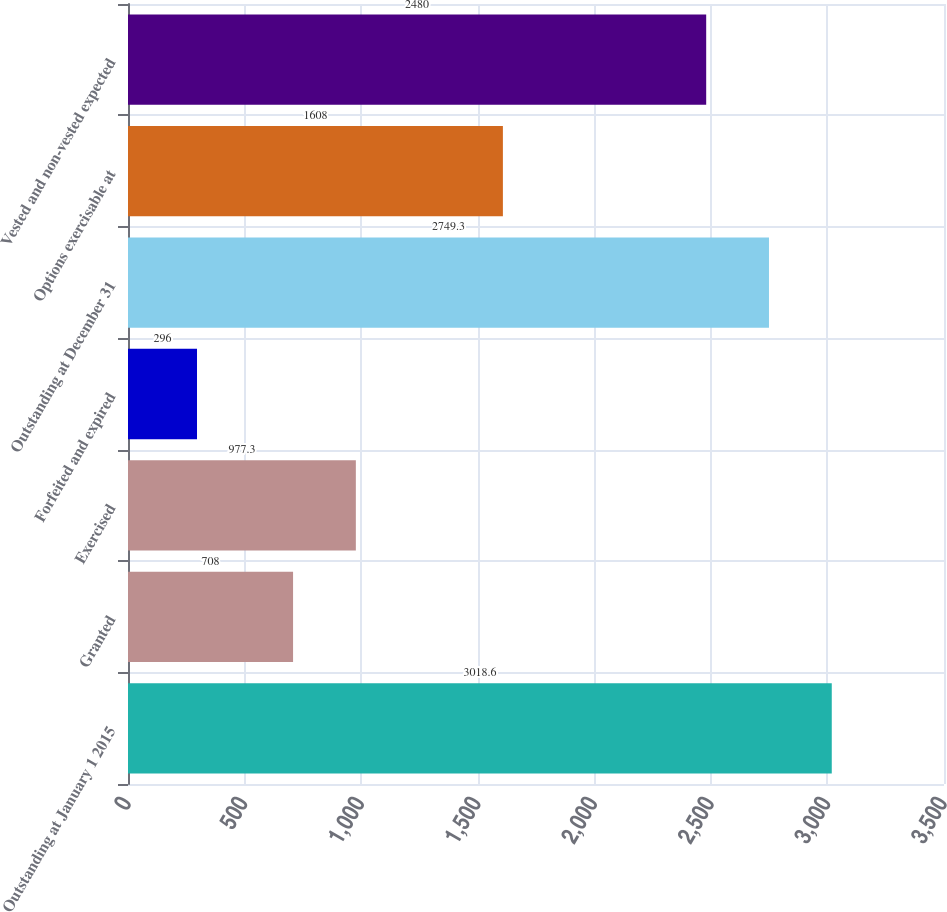<chart> <loc_0><loc_0><loc_500><loc_500><bar_chart><fcel>Outstanding at January 1 2015<fcel>Granted<fcel>Exercised<fcel>Forfeited and expired<fcel>Outstanding at December 31<fcel>Options exercisable at<fcel>Vested and non-vested expected<nl><fcel>3018.6<fcel>708<fcel>977.3<fcel>296<fcel>2749.3<fcel>1608<fcel>2480<nl></chart> 